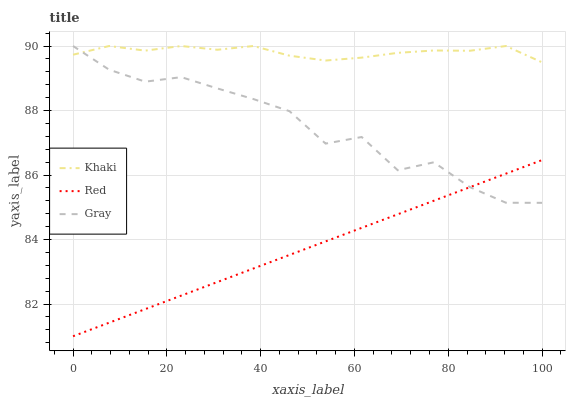Does Red have the minimum area under the curve?
Answer yes or no. Yes. Does Khaki have the maximum area under the curve?
Answer yes or no. Yes. Does Khaki have the minimum area under the curve?
Answer yes or no. No. Does Red have the maximum area under the curve?
Answer yes or no. No. Is Red the smoothest?
Answer yes or no. Yes. Is Gray the roughest?
Answer yes or no. Yes. Is Khaki the smoothest?
Answer yes or no. No. Is Khaki the roughest?
Answer yes or no. No. Does Red have the lowest value?
Answer yes or no. Yes. Does Khaki have the lowest value?
Answer yes or no. No. Does Khaki have the highest value?
Answer yes or no. Yes. Does Red have the highest value?
Answer yes or no. No. Is Red less than Khaki?
Answer yes or no. Yes. Is Khaki greater than Red?
Answer yes or no. Yes. Does Gray intersect Red?
Answer yes or no. Yes. Is Gray less than Red?
Answer yes or no. No. Is Gray greater than Red?
Answer yes or no. No. Does Red intersect Khaki?
Answer yes or no. No. 